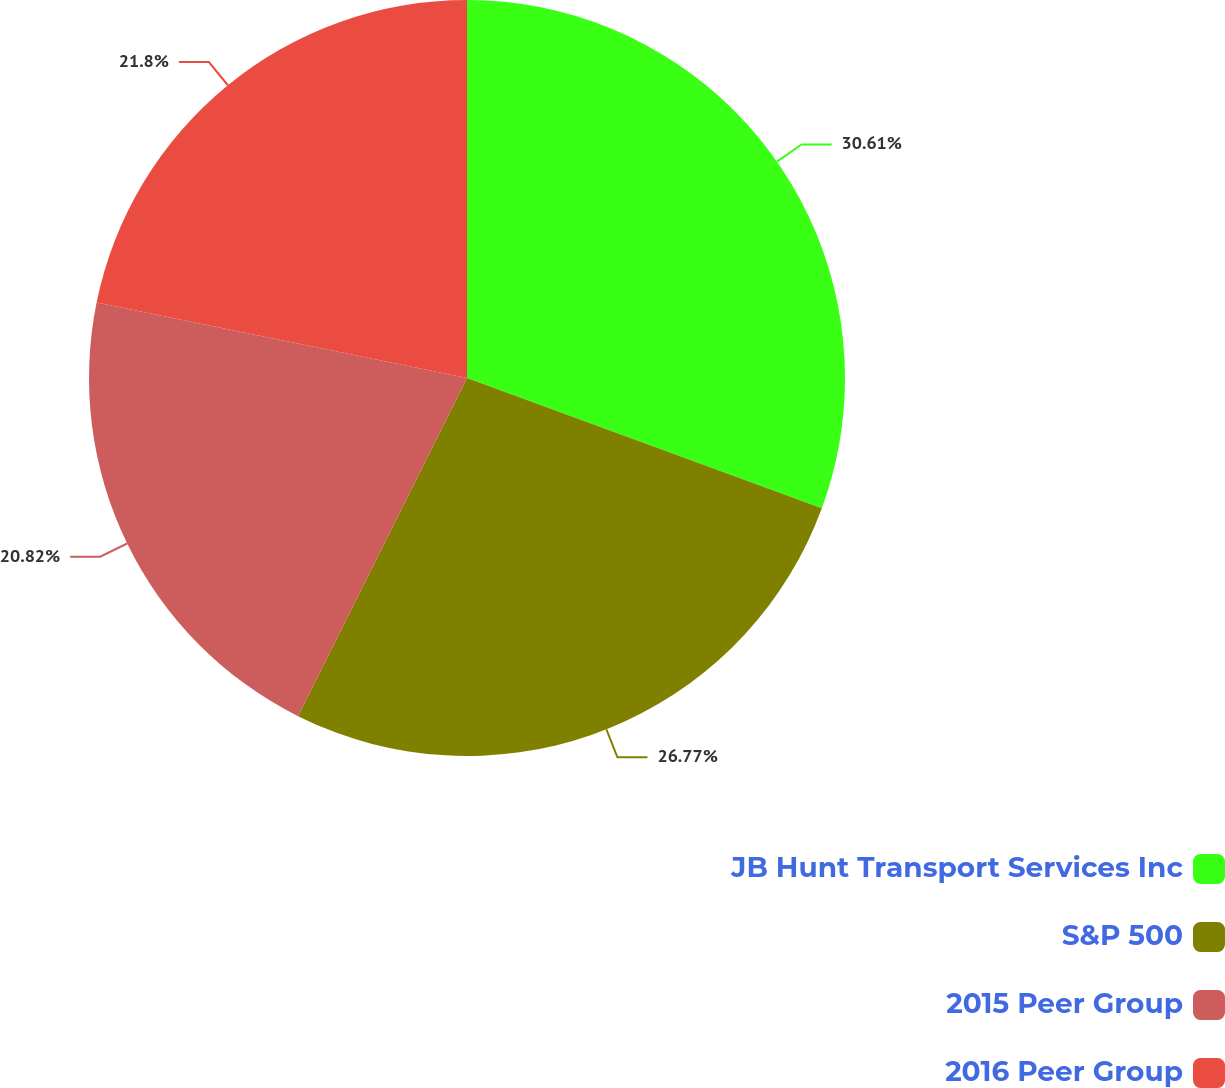Convert chart to OTSL. <chart><loc_0><loc_0><loc_500><loc_500><pie_chart><fcel>JB Hunt Transport Services Inc<fcel>S&P 500<fcel>2015 Peer Group<fcel>2016 Peer Group<nl><fcel>30.6%<fcel>26.77%<fcel>20.82%<fcel>21.8%<nl></chart> 